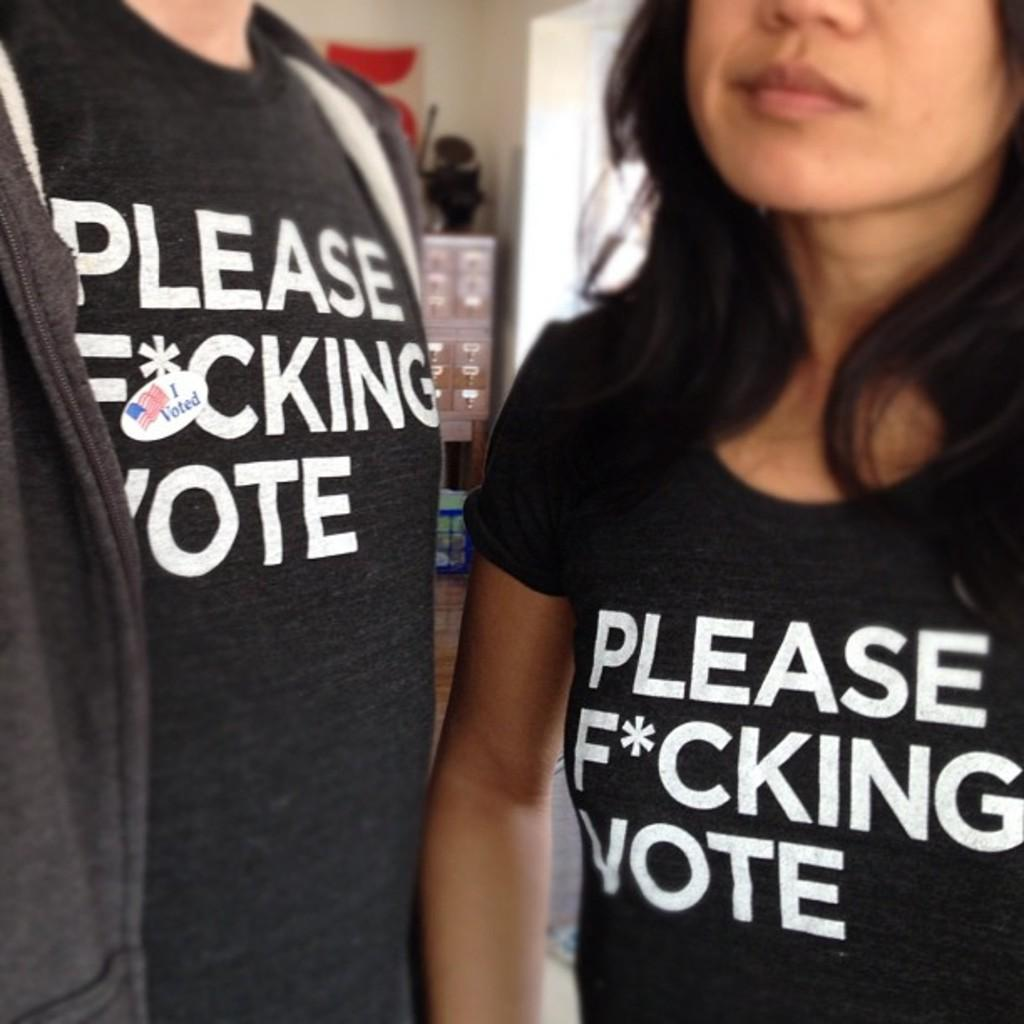<image>
Share a concise interpretation of the image provided. People wearing black shirts that say "Please vote". 